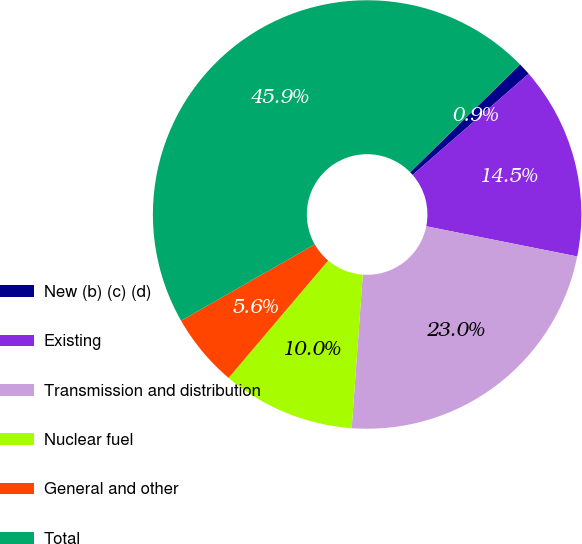Convert chart to OTSL. <chart><loc_0><loc_0><loc_500><loc_500><pie_chart><fcel>New (b) (c) (d)<fcel>Existing<fcel>Transmission and distribution<fcel>Nuclear fuel<fcel>General and other<fcel>Total<nl><fcel>0.94%<fcel>14.54%<fcel>23.01%<fcel>10.04%<fcel>5.55%<fcel>45.91%<nl></chart> 